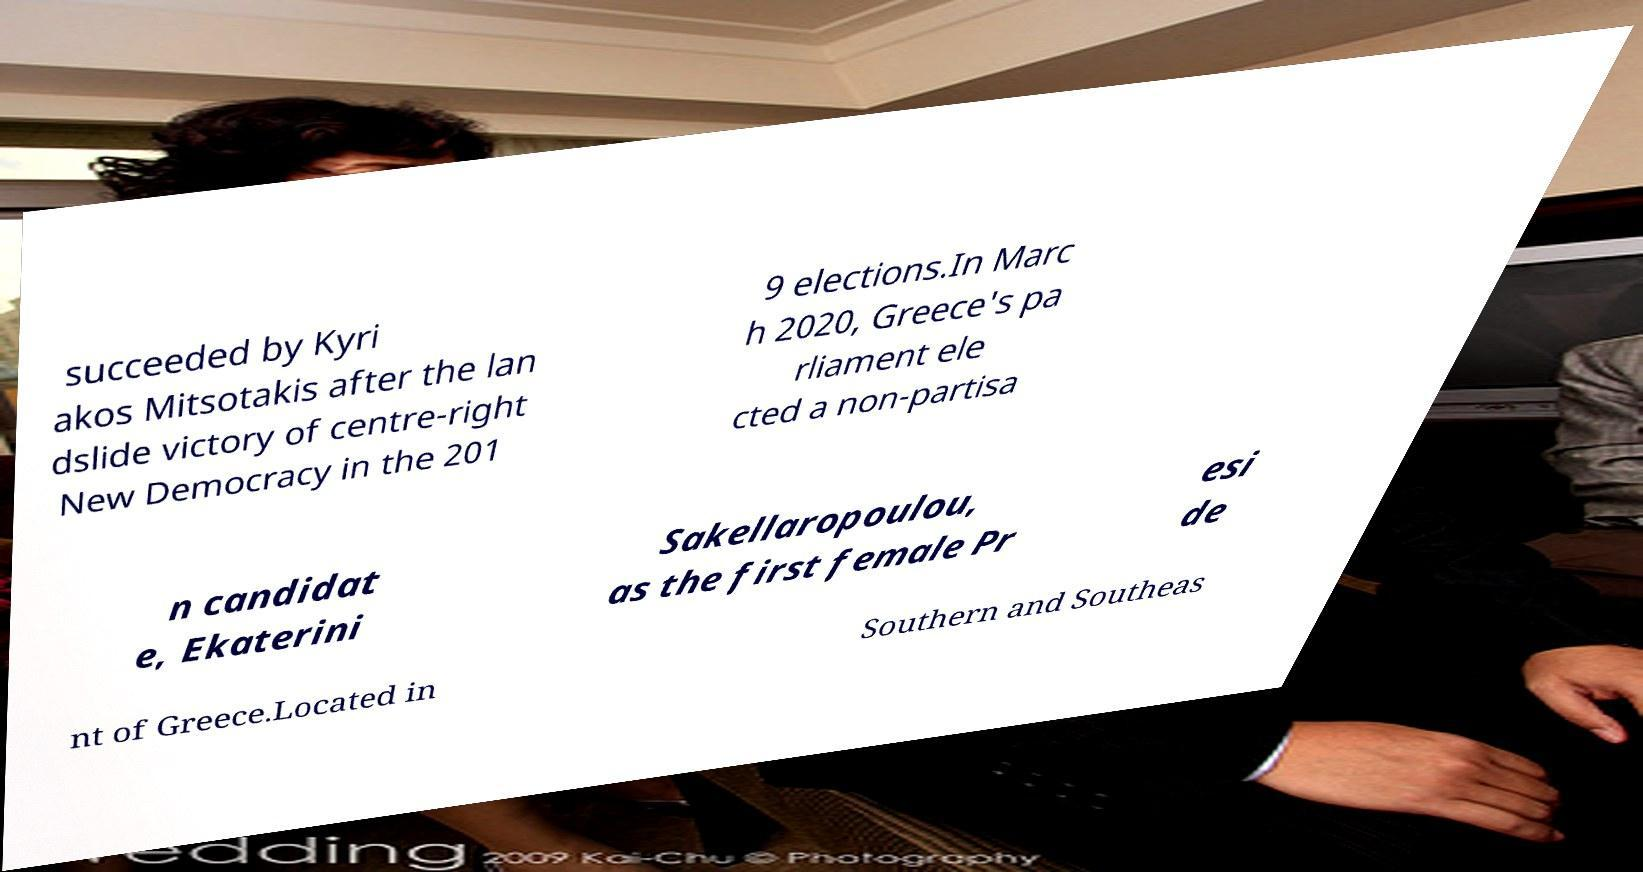Could you extract and type out the text from this image? succeeded by Kyri akos Mitsotakis after the lan dslide victory of centre-right New Democracy in the 201 9 elections.In Marc h 2020, Greece's pa rliament ele cted a non-partisa n candidat e, Ekaterini Sakellaropoulou, as the first female Pr esi de nt of Greece.Located in Southern and Southeas 